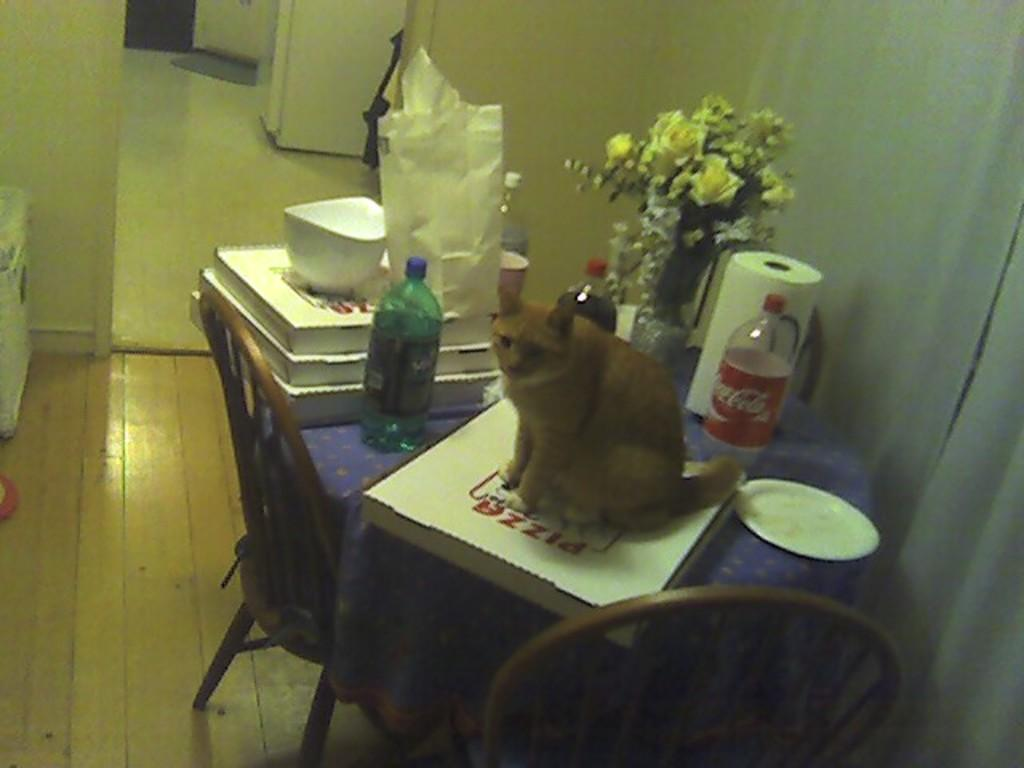What type of animal is present in the image? There is a cat in the image. What objects related to reading can be seen in the image? There are books in the image. What type of decorative item is present in the image? There is a flower vase in the image. How many water bottles are visible in the image? There are 2 water bottles in the image. What item might be used for cleaning or wiping in the image? There is a tissue roll in the image. What type of dishware is present in the image? There is a plate in the image. What type of beverage container is present in the image? There is a glass in the image. How many chairs are visible in the image? There are 2 chairs in the image. What type of waves can be seen in the image? There are no waves present in the image. Who is the manager of the cat in the image? The image does not depict a cat with a manager, as cats do not have managers. 